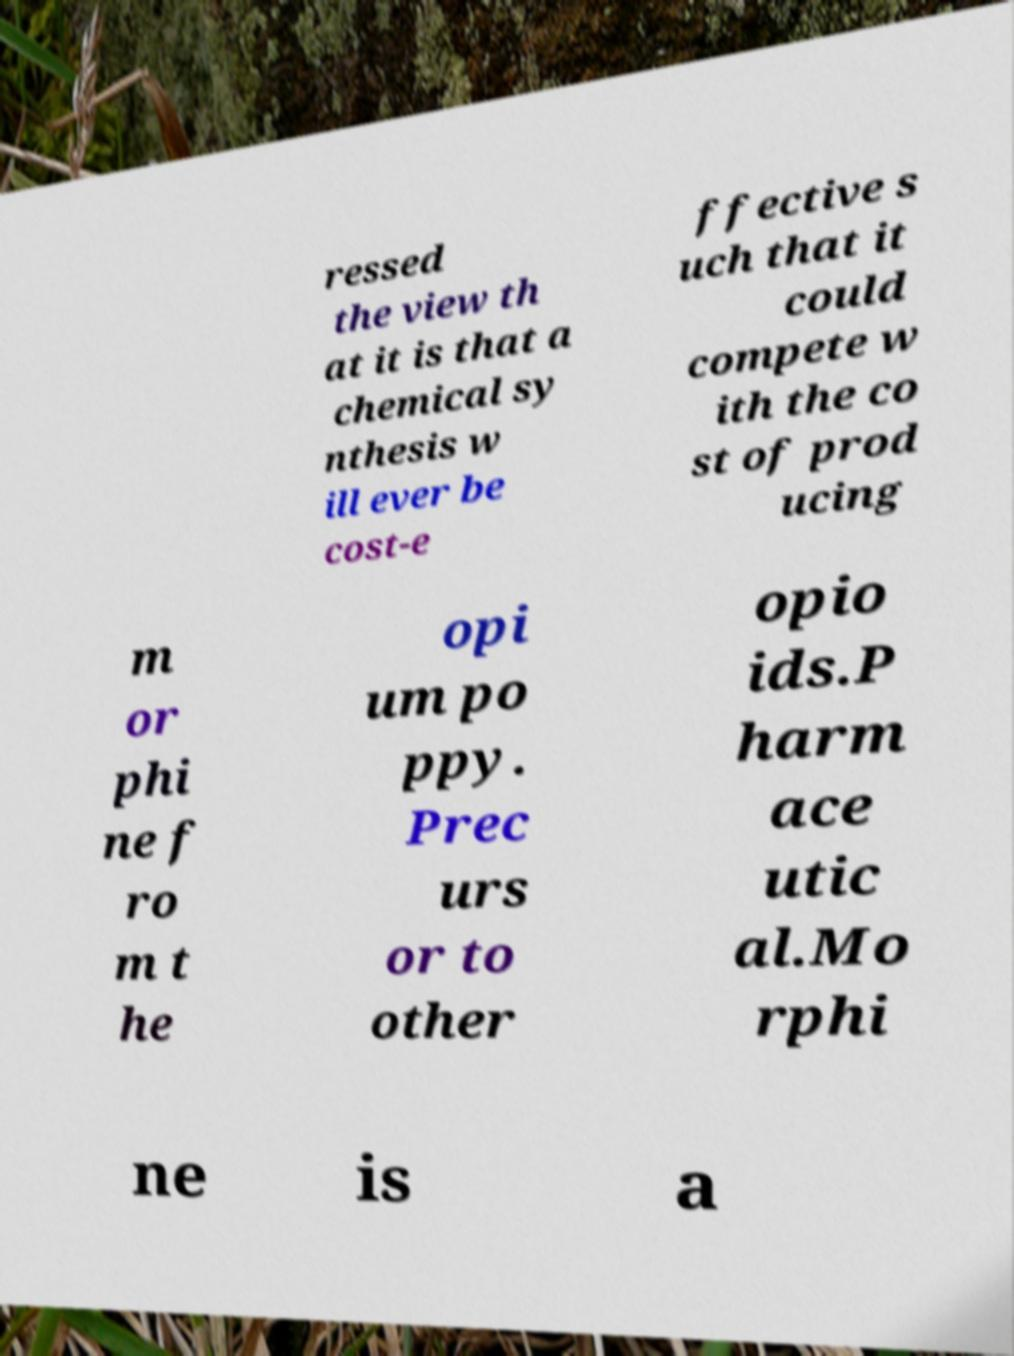I need the written content from this picture converted into text. Can you do that? ressed the view th at it is that a chemical sy nthesis w ill ever be cost-e ffective s uch that it could compete w ith the co st of prod ucing m or phi ne f ro m t he opi um po ppy. Prec urs or to other opio ids.P harm ace utic al.Mo rphi ne is a 